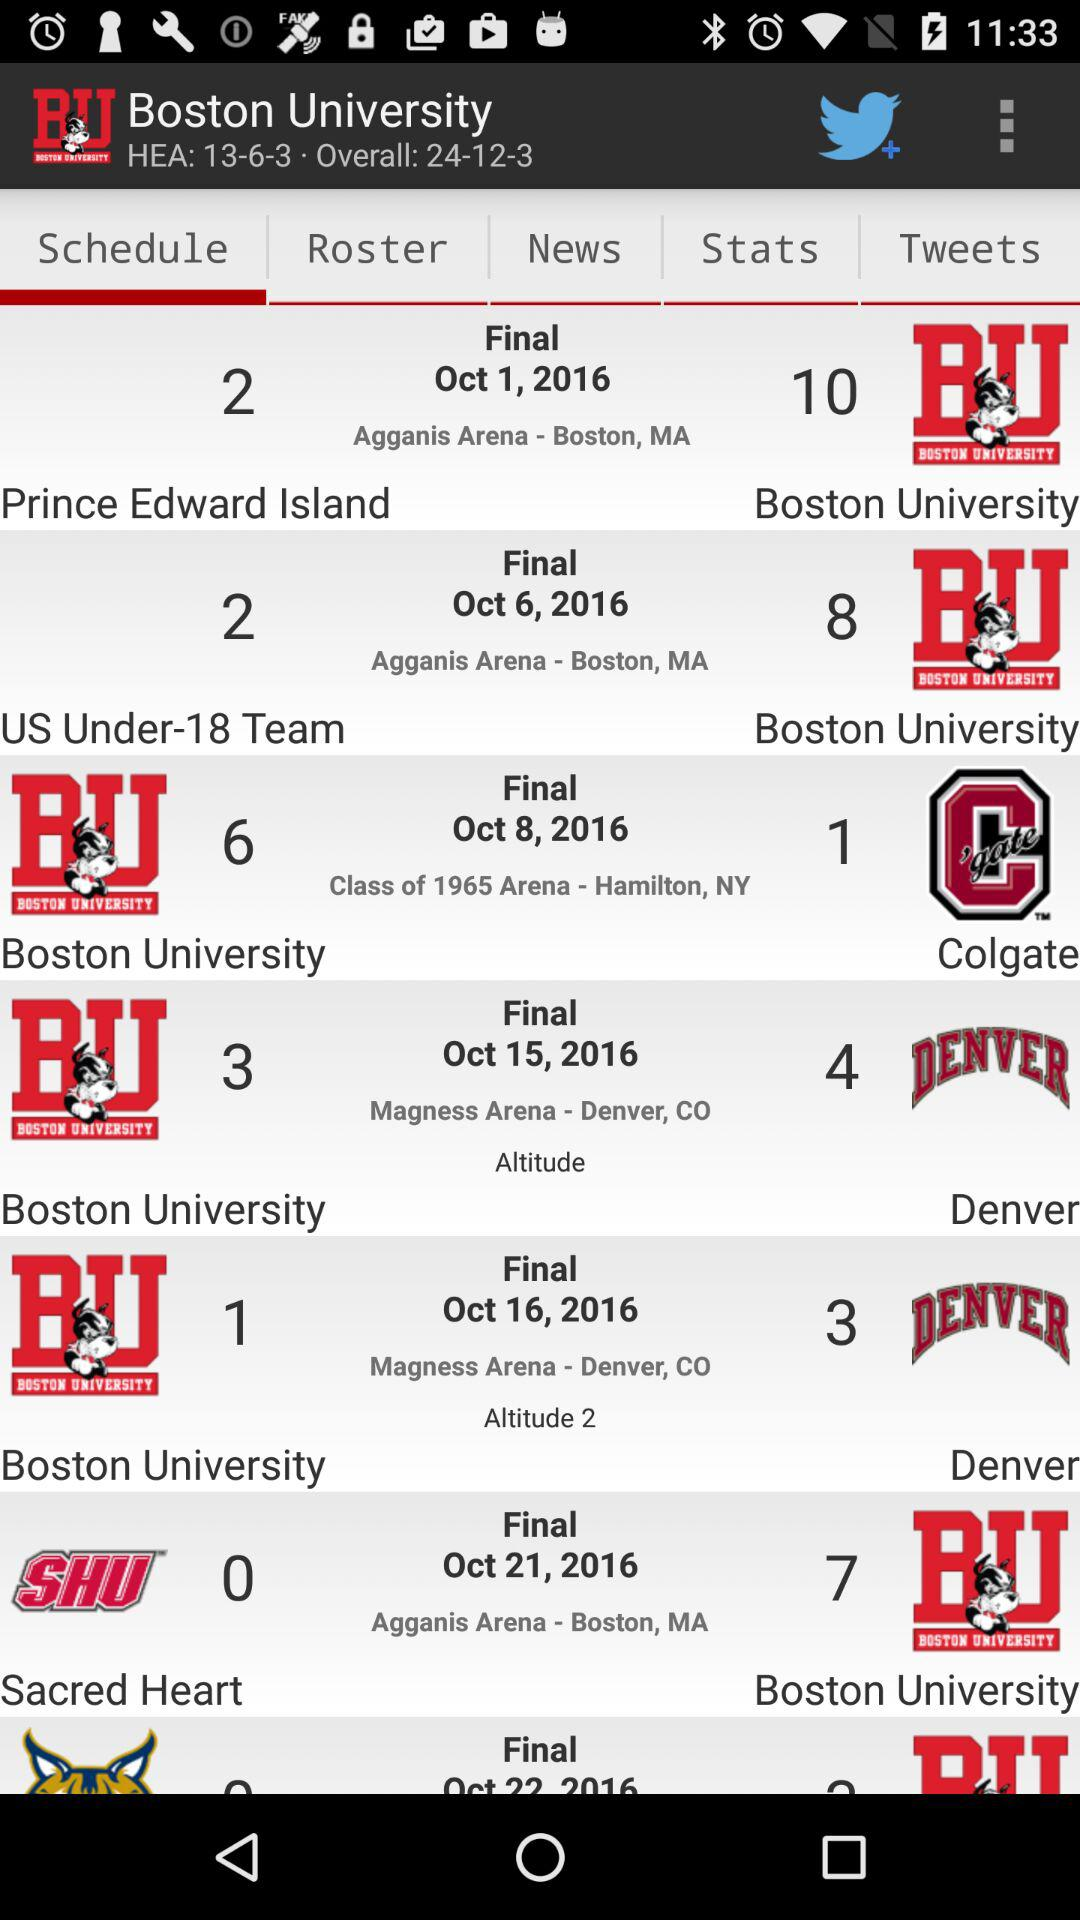What was the location of the "Sacred Heart" team's match? The location was Agganis Arena in Boston, MA. 